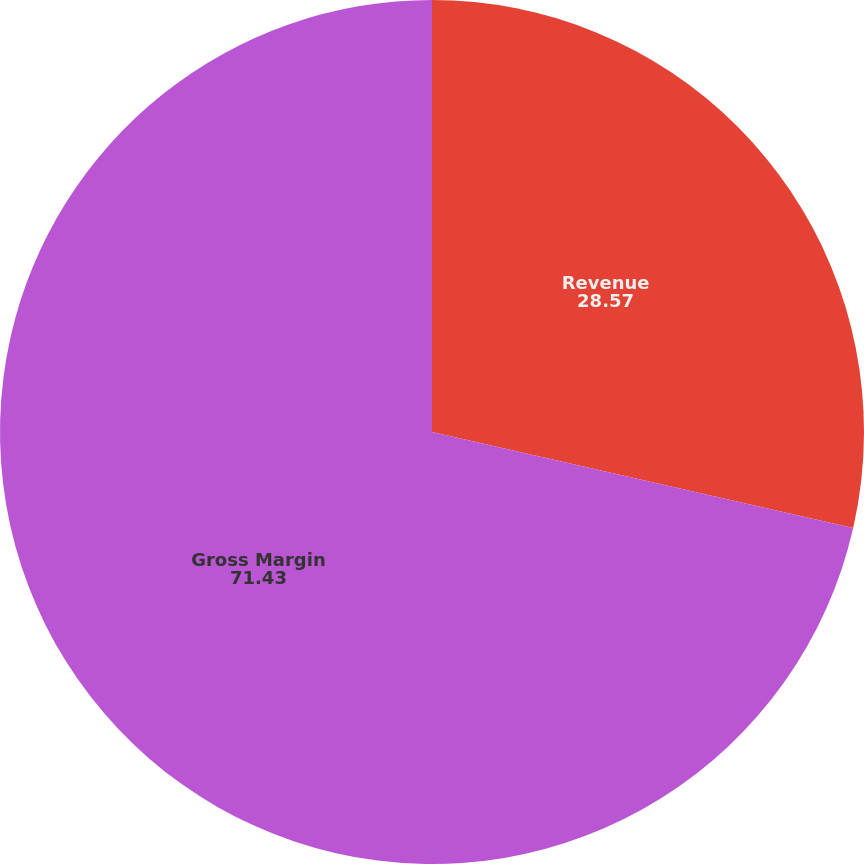<chart> <loc_0><loc_0><loc_500><loc_500><pie_chart><fcel>Revenue<fcel>Gross Margin<nl><fcel>28.57%<fcel>71.43%<nl></chart> 